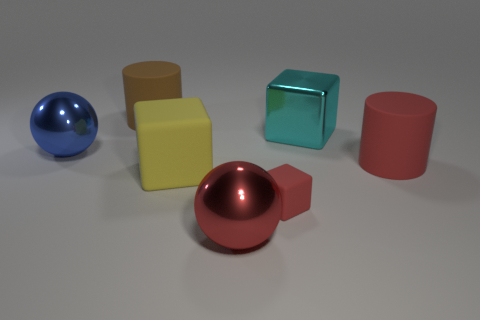Subtract all large cyan metal cubes. How many cubes are left? 2 Add 2 big red matte cylinders. How many objects exist? 9 Subtract all cubes. How many objects are left? 4 Subtract 0 yellow balls. How many objects are left? 7 Subtract all small cyan metallic blocks. Subtract all big yellow objects. How many objects are left? 6 Add 5 red metallic spheres. How many red metallic spheres are left? 6 Add 5 small cyan rubber things. How many small cyan rubber things exist? 5 